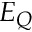<formula> <loc_0><loc_0><loc_500><loc_500>E _ { Q }</formula> 